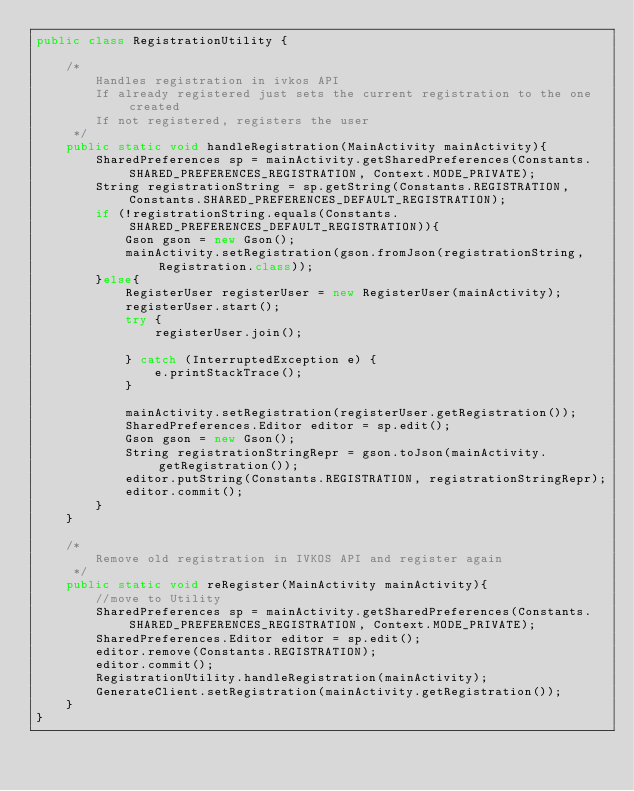Convert code to text. <code><loc_0><loc_0><loc_500><loc_500><_Java_>public class RegistrationUtility {

    /*
        Handles registration in ivkos API
        If already registered just sets the current registration to the one created
        If not registered, registers the user
     */
    public static void handleRegistration(MainActivity mainActivity){
        SharedPreferences sp = mainActivity.getSharedPreferences(Constants.SHARED_PREFERENCES_REGISTRATION, Context.MODE_PRIVATE);
        String registrationString = sp.getString(Constants.REGISTRATION, Constants.SHARED_PREFERENCES_DEFAULT_REGISTRATION);
        if (!registrationString.equals(Constants.SHARED_PREFERENCES_DEFAULT_REGISTRATION)){
            Gson gson = new Gson();
            mainActivity.setRegistration(gson.fromJson(registrationString, Registration.class));
        }else{
            RegisterUser registerUser = new RegisterUser(mainActivity);
            registerUser.start();
            try {
                registerUser.join();

            } catch (InterruptedException e) {
                e.printStackTrace();
            }

            mainActivity.setRegistration(registerUser.getRegistration());
            SharedPreferences.Editor editor = sp.edit();
            Gson gson = new Gson();
            String registrationStringRepr = gson.toJson(mainActivity.getRegistration());
            editor.putString(Constants.REGISTRATION, registrationStringRepr);
            editor.commit();
        }
    }

    /*
        Remove old registration in IVKOS API and register again
     */
    public static void reRegister(MainActivity mainActivity){
        //move to Utility
        SharedPreferences sp = mainActivity.getSharedPreferences(Constants.SHARED_PREFERENCES_REGISTRATION, Context.MODE_PRIVATE);
        SharedPreferences.Editor editor = sp.edit();
        editor.remove(Constants.REGISTRATION);
        editor.commit();
        RegistrationUtility.handleRegistration(mainActivity);
        GenerateClient.setRegistration(mainActivity.getRegistration());
    }
}
</code> 